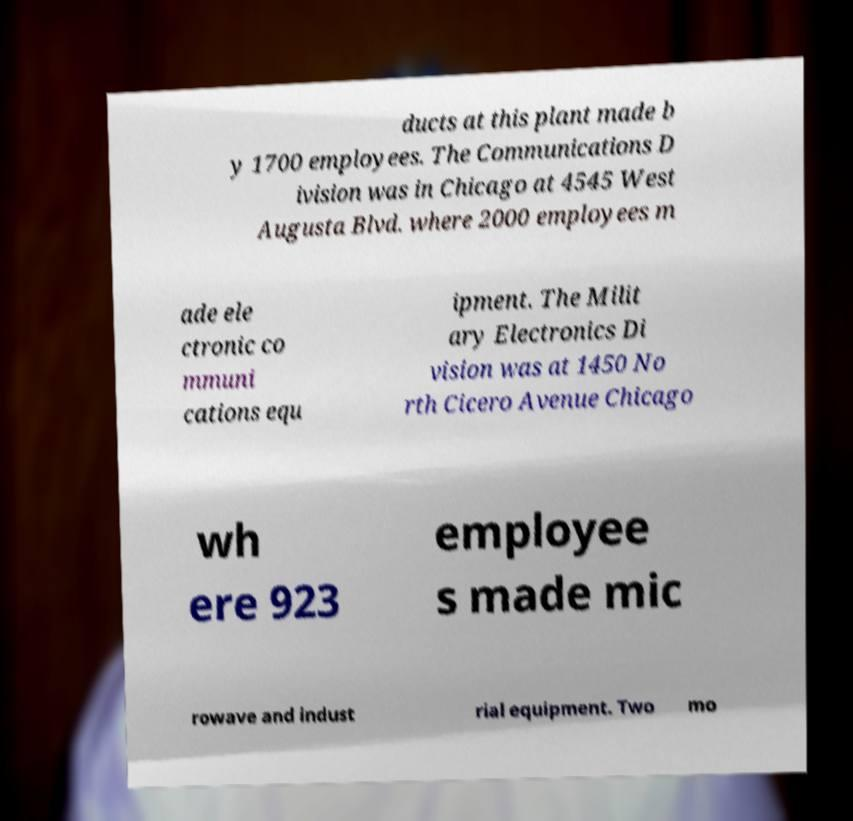What messages or text are displayed in this image? I need them in a readable, typed format. ducts at this plant made b y 1700 employees. The Communications D ivision was in Chicago at 4545 West Augusta Blvd. where 2000 employees m ade ele ctronic co mmuni cations equ ipment. The Milit ary Electronics Di vision was at 1450 No rth Cicero Avenue Chicago wh ere 923 employee s made mic rowave and indust rial equipment. Two mo 